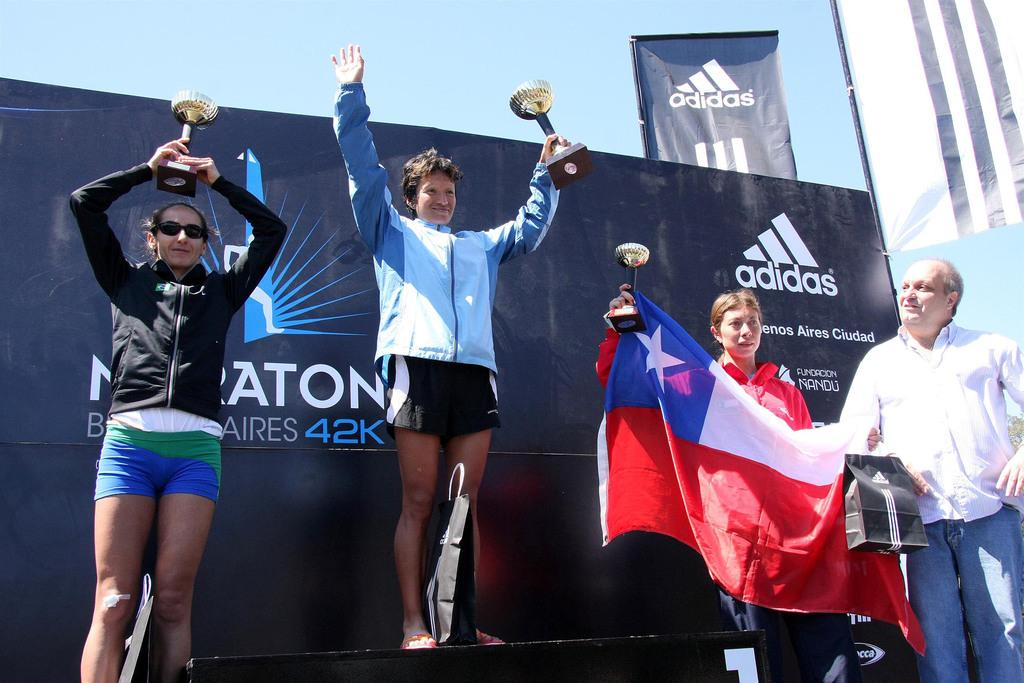<image>
Share a concise interpretation of the image provided. People holding trophies and posing in front of an ADIDAS ad. 